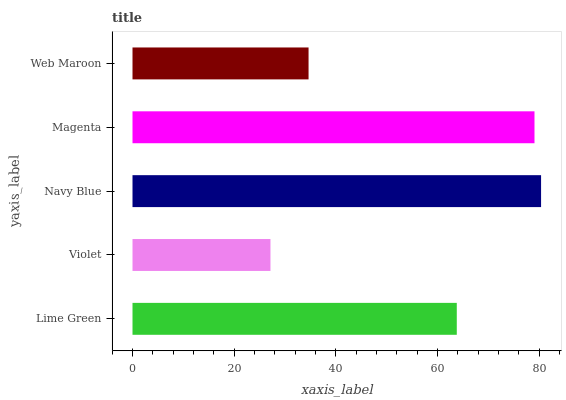Is Violet the minimum?
Answer yes or no. Yes. Is Navy Blue the maximum?
Answer yes or no. Yes. Is Navy Blue the minimum?
Answer yes or no. No. Is Violet the maximum?
Answer yes or no. No. Is Navy Blue greater than Violet?
Answer yes or no. Yes. Is Violet less than Navy Blue?
Answer yes or no. Yes. Is Violet greater than Navy Blue?
Answer yes or no. No. Is Navy Blue less than Violet?
Answer yes or no. No. Is Lime Green the high median?
Answer yes or no. Yes. Is Lime Green the low median?
Answer yes or no. Yes. Is Web Maroon the high median?
Answer yes or no. No. Is Violet the low median?
Answer yes or no. No. 